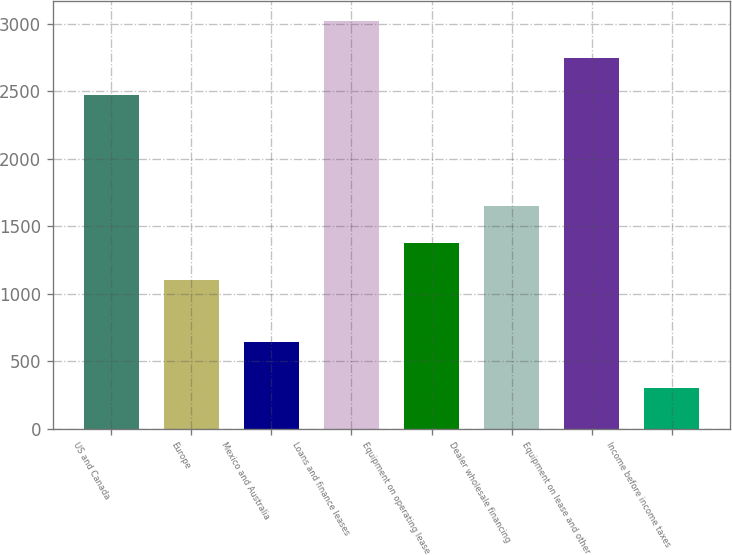<chart> <loc_0><loc_0><loc_500><loc_500><bar_chart><fcel>US and Canada<fcel>Europe<fcel>Mexico and Australia<fcel>Loans and finance leases<fcel>Equipment on operating lease<fcel>Dealer wholesale financing<fcel>Equipment on lease and other<fcel>Income before income taxes<nl><fcel>2474.9<fcel>1104.8<fcel>643.7<fcel>3016.88<fcel>1375.79<fcel>1646.78<fcel>2745.89<fcel>306.5<nl></chart> 